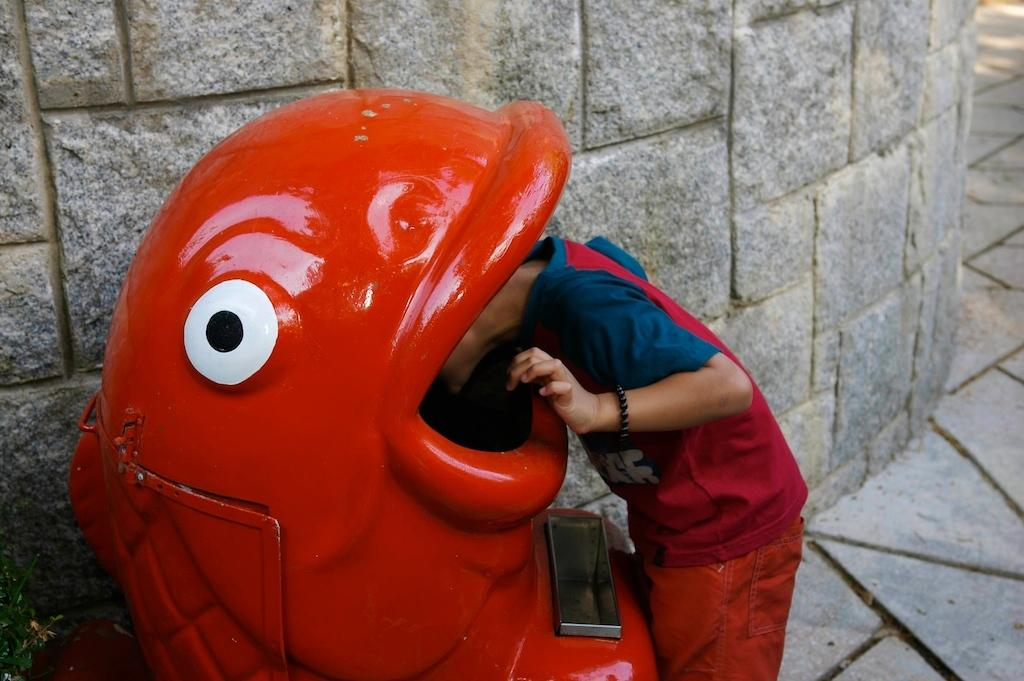What color is the dustbin in the image? The dustbin in the image is red. What is the person in the image doing? The person is looking at the dustbin. What can be seen in the background of the image? There is a stone wall in the background of the image. What type of power does the person in the image possess? There is no indication in the image that the person possesses any special power. 